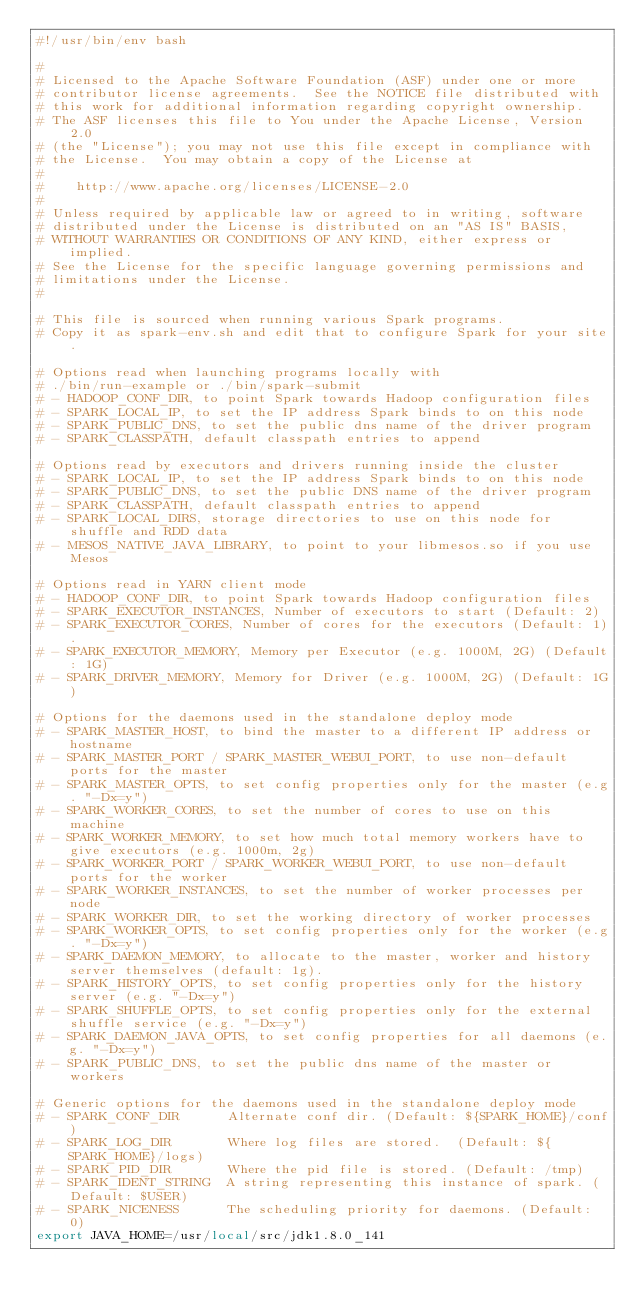<code> <loc_0><loc_0><loc_500><loc_500><_Bash_>#!/usr/bin/env bash

#
# Licensed to the Apache Software Foundation (ASF) under one or more
# contributor license agreements.  See the NOTICE file distributed with
# this work for additional information regarding copyright ownership.
# The ASF licenses this file to You under the Apache License, Version 2.0
# (the "License"); you may not use this file except in compliance with
# the License.  You may obtain a copy of the License at
#
#    http://www.apache.org/licenses/LICENSE-2.0
#
# Unless required by applicable law or agreed to in writing, software
# distributed under the License is distributed on an "AS IS" BASIS,
# WITHOUT WARRANTIES OR CONDITIONS OF ANY KIND, either express or implied.
# See the License for the specific language governing permissions and
# limitations under the License.
#

# This file is sourced when running various Spark programs.
# Copy it as spark-env.sh and edit that to configure Spark for your site.

# Options read when launching programs locally with
# ./bin/run-example or ./bin/spark-submit
# - HADOOP_CONF_DIR, to point Spark towards Hadoop configuration files
# - SPARK_LOCAL_IP, to set the IP address Spark binds to on this node
# - SPARK_PUBLIC_DNS, to set the public dns name of the driver program
# - SPARK_CLASSPATH, default classpath entries to append

# Options read by executors and drivers running inside the cluster
# - SPARK_LOCAL_IP, to set the IP address Spark binds to on this node
# - SPARK_PUBLIC_DNS, to set the public DNS name of the driver program
# - SPARK_CLASSPATH, default classpath entries to append
# - SPARK_LOCAL_DIRS, storage directories to use on this node for shuffle and RDD data
# - MESOS_NATIVE_JAVA_LIBRARY, to point to your libmesos.so if you use Mesos

# Options read in YARN client mode
# - HADOOP_CONF_DIR, to point Spark towards Hadoop configuration files
# - SPARK_EXECUTOR_INSTANCES, Number of executors to start (Default: 2)
# - SPARK_EXECUTOR_CORES, Number of cores for the executors (Default: 1).
# - SPARK_EXECUTOR_MEMORY, Memory per Executor (e.g. 1000M, 2G) (Default: 1G)
# - SPARK_DRIVER_MEMORY, Memory for Driver (e.g. 1000M, 2G) (Default: 1G)

# Options for the daemons used in the standalone deploy mode
# - SPARK_MASTER_HOST, to bind the master to a different IP address or hostname
# - SPARK_MASTER_PORT / SPARK_MASTER_WEBUI_PORT, to use non-default ports for the master
# - SPARK_MASTER_OPTS, to set config properties only for the master (e.g. "-Dx=y")
# - SPARK_WORKER_CORES, to set the number of cores to use on this machine
# - SPARK_WORKER_MEMORY, to set how much total memory workers have to give executors (e.g. 1000m, 2g)
# - SPARK_WORKER_PORT / SPARK_WORKER_WEBUI_PORT, to use non-default ports for the worker
# - SPARK_WORKER_INSTANCES, to set the number of worker processes per node
# - SPARK_WORKER_DIR, to set the working directory of worker processes
# - SPARK_WORKER_OPTS, to set config properties only for the worker (e.g. "-Dx=y")
# - SPARK_DAEMON_MEMORY, to allocate to the master, worker and history server themselves (default: 1g).
# - SPARK_HISTORY_OPTS, to set config properties only for the history server (e.g. "-Dx=y")
# - SPARK_SHUFFLE_OPTS, to set config properties only for the external shuffle service (e.g. "-Dx=y")
# - SPARK_DAEMON_JAVA_OPTS, to set config properties for all daemons (e.g. "-Dx=y")
# - SPARK_PUBLIC_DNS, to set the public dns name of the master or workers

# Generic options for the daemons used in the standalone deploy mode
# - SPARK_CONF_DIR      Alternate conf dir. (Default: ${SPARK_HOME}/conf)
# - SPARK_LOG_DIR       Where log files are stored.  (Default: ${SPARK_HOME}/logs)
# - SPARK_PID_DIR       Where the pid file is stored. (Default: /tmp)
# - SPARK_IDENT_STRING  A string representing this instance of spark. (Default: $USER)
# - SPARK_NICENESS      The scheduling priority for daemons. (Default: 0)
export JAVA_HOME=/usr/local/src/jdk1.8.0_141</code> 